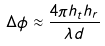Convert formula to latex. <formula><loc_0><loc_0><loc_500><loc_500>\Delta \phi \approx \frac { 4 \pi h _ { t } h _ { r } } { \lambda d }</formula> 